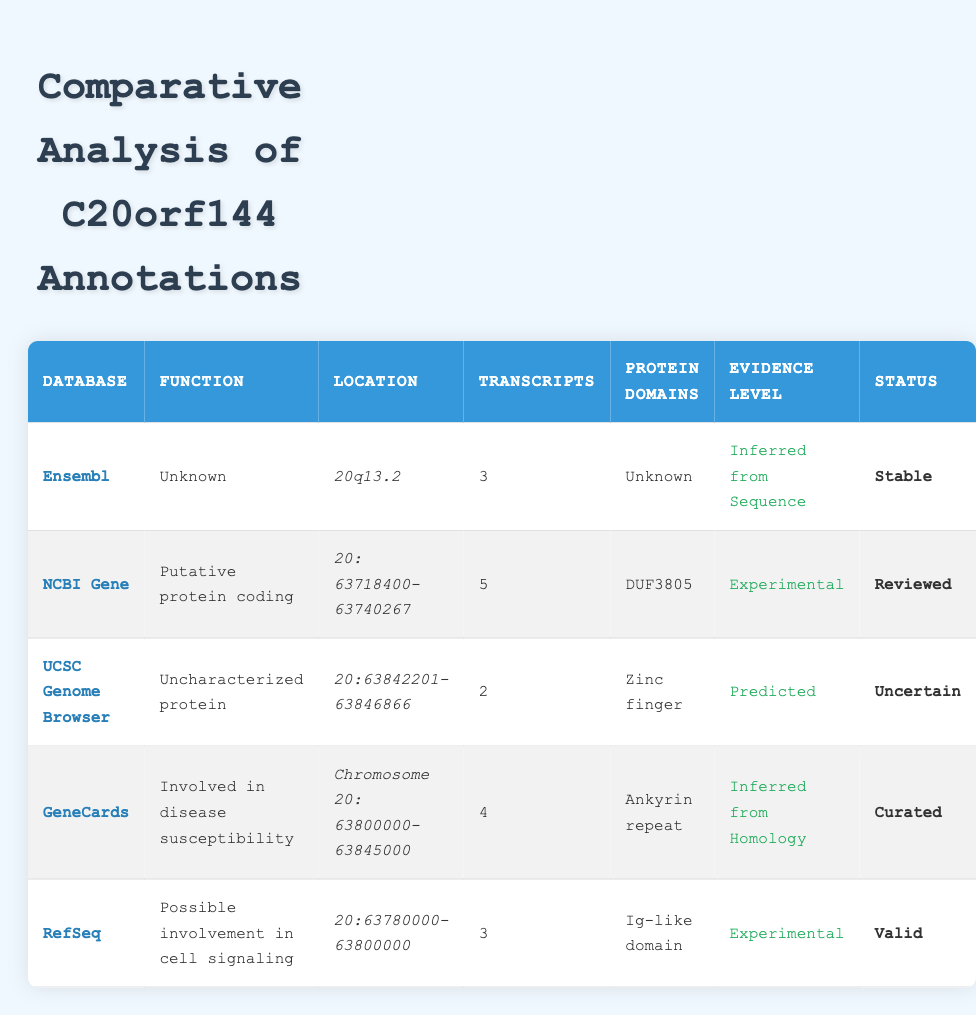What is the function of the C20orf144 gene according to the NCBI Gene database? The function of the C20orf144 gene in the NCBI Gene database is listed as "Putative protein coding."
Answer: Putative protein coding How many transcripts are reported for C20orf144 in the UCSC Genome Browser? The UCSC Genome Browser reports 2 transcripts for the C20orf144 gene.
Answer: 2 Which database indicates that C20orf144 is involved in disease susceptibility? According to GeneCards, C20orf144 is indicated to be involved in disease susceptibility.
Answer: GeneCards Is the protein domain information for C20orf144 consistent across all databases? No, the protein domain information is not consistent; for example, NCBI Gene mentions "DUF3805," while UCSC Genome Browser mentions "Zinc finger."
Answer: No What is the average number of transcripts reported across all databases? The number of transcripts for each database is 3, 5, 2, 4, and 3, respectively. Summing these gives 17, and dividing by 5 databases (17/5) gives an average of 3.4 transcripts.
Answer: 3.4 Which database has C20orf144 marked as "Curated"? The GeneCards database has C20orf144 marked as "Curated".
Answer: GeneCards Is the evidence level for C20orf144 in Ensembl database classified as "Experimental"? No, the evidence level for C20orf144 in the Ensembl database is classified as "Inferred from Sequence."
Answer: No In which database is the gene location of C20orf144 noted as "20q13.2"? The Ensembl database notes the gene location of C20orf144 as "20q13.2".
Answer: Ensembl Which database provides the highest number of transcripts for C20orf144, and how many are reported? The NCBI Gene database provides the highest number of transcripts, reporting a total of 5 transcripts for C20orf144.
Answer: NCBI Gene, 5 transcripts What is the evidence level for the C20orf144 gene according to RefSeq? The evidence level for C20orf144 according to RefSeq is classified as "Experimental."
Answer: Experimental 